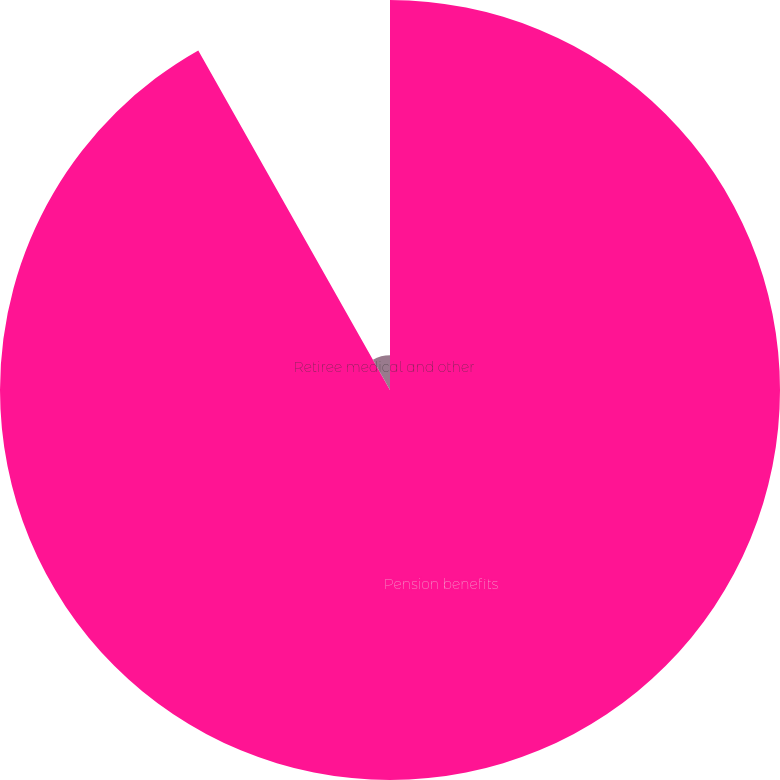<chart> <loc_0><loc_0><loc_500><loc_500><pie_chart><fcel>Pension benefits<fcel>Retiree medical and other<nl><fcel>91.82%<fcel>8.18%<nl></chart> 